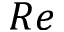Convert formula to latex. <formula><loc_0><loc_0><loc_500><loc_500>R e</formula> 